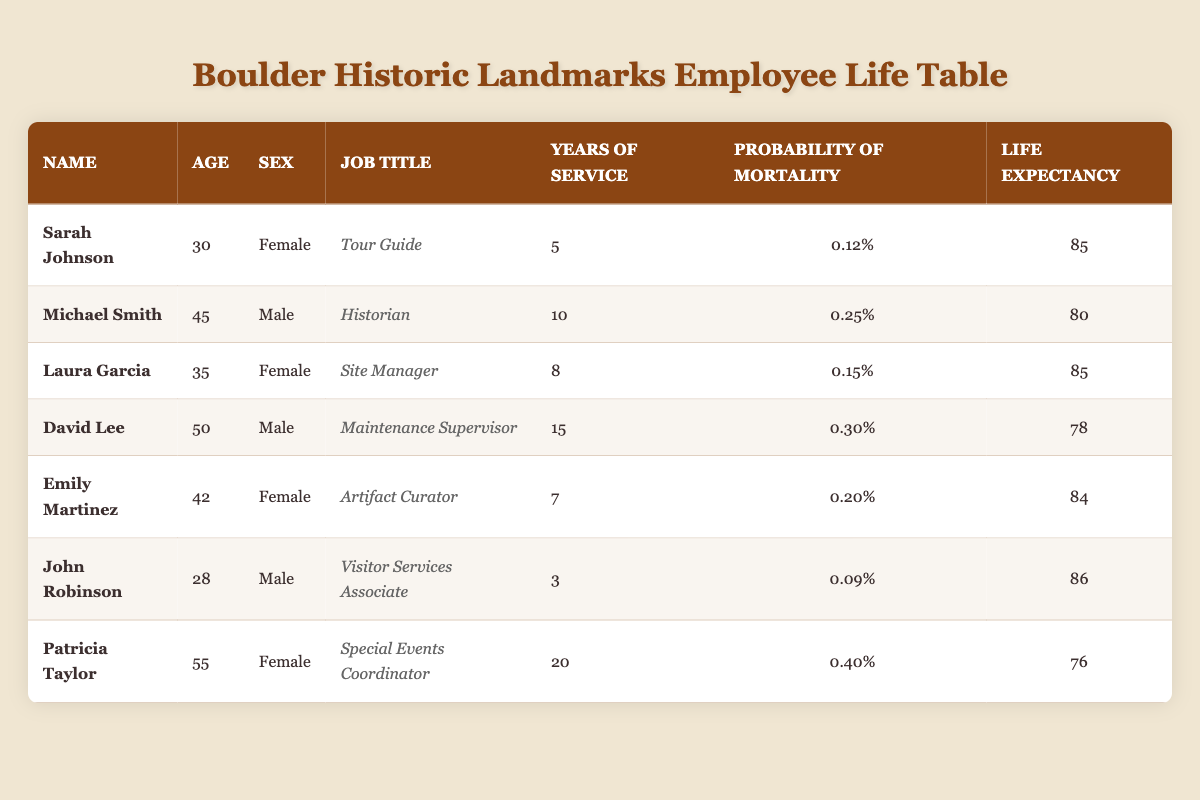What is the life expectancy of Michael Smith? The table lists Michael Smith's life expectancy, which is stated directly next to his name in the relevant column.
Answer: 80 Who is the oldest employee listed in the table? By comparing the ages in the Age column, Patricia Taylor, at age 55, is the oldest employee.
Answer: Patricia Taylor What is the probability of mortality for John Robinson? The probability of mortality is provided directly in the table for John Robinson, reflecting his risk category.
Answer: 0.09% Calculate the average life expectancy of all employees in the table. To find the average, we sum the life expectancies: (85 + 80 + 85 + 78 + 84 + 86 + 76) = 554. There are 7 employees, so the average is 554 / 7 = 79.14.
Answer: 79.14 Is the probability of mortality for Laura Garcia higher than that of Sarah Johnson? Laura Garcia's probability of mortality is 0.15%, while Sarah Johnson's is 0.12%. Since 0.15% is greater than 0.12%, the statement is true.
Answer: Yes Which employee has the highest years of service? By examining the Years of Service column, Patricia Taylor has the highest value at 20 years.
Answer: Patricia Taylor What is the combined probability of mortality for all female employees listed? The female employees are Sarah Johnson (0.12%), Laura Garcia (0.15%), Emily Martinez (0.20%), and Patricia Taylor (0.40%). Summing these gives 0.12 + 0.15 + 0.20 + 0.40 = 0.87%.
Answer: 0.87% Are there more male employees or female employees in the table? Counting the gender breakdown in the table, there are 3 female employees (Sarah, Laura, Emily, Patricia) and 4 male employees (Michael, David, John). Since 4 is greater than 3, the answer is male.
Answer: Male What is the average age of employees who have over 10 years of service? Employees with over 10 years are David Lee (50) and Patricia Taylor (55). The average is (50 + 55) / 2 = 52.5.
Answer: 52.5 